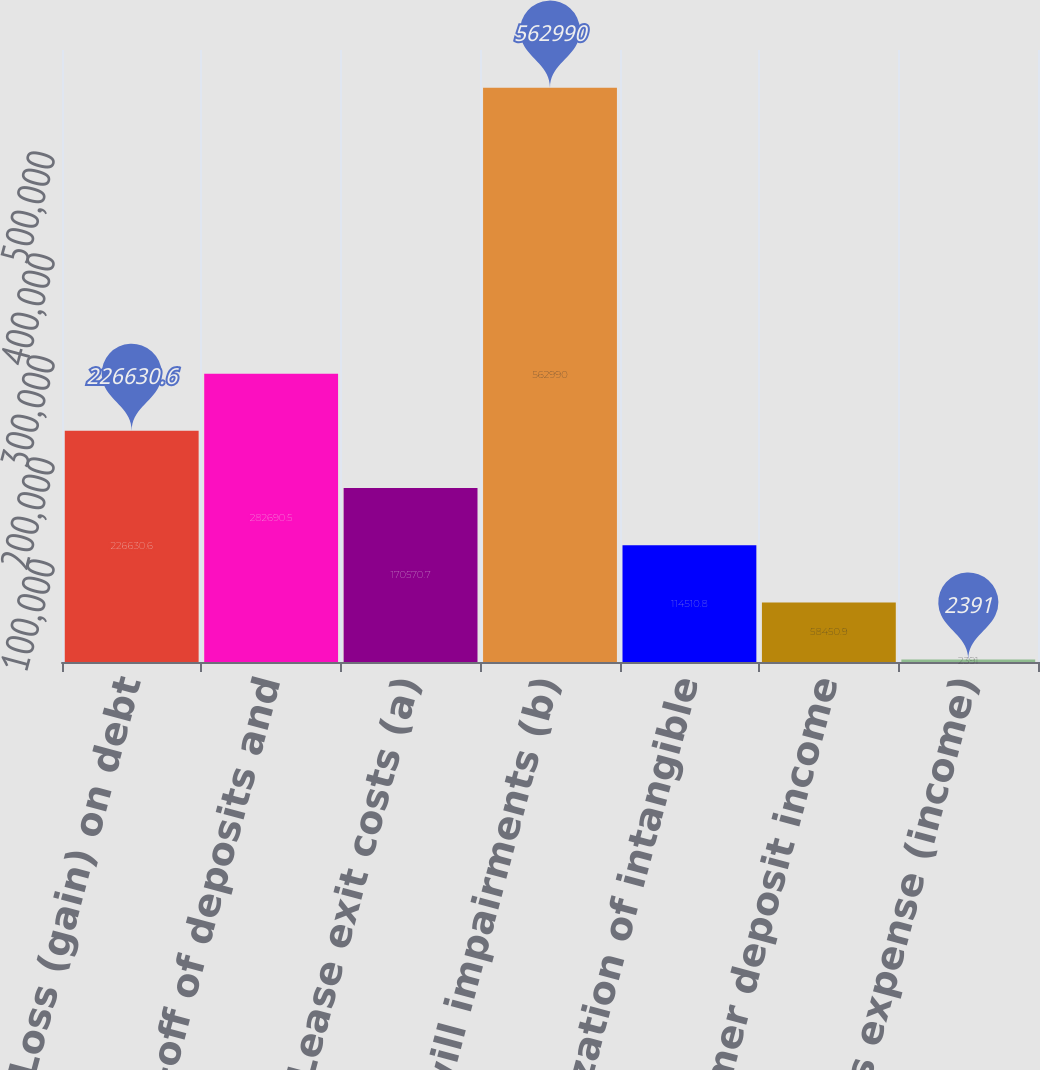<chart> <loc_0><loc_0><loc_500><loc_500><bar_chart><fcel>Loss (gain) on debt<fcel>Write-off of deposits and<fcel>Lease exit costs (a)<fcel>Goodwill impairments (b)<fcel>Amortization of intangible<fcel>Customer deposit income<fcel>Miscellaneous expense (income)<nl><fcel>226631<fcel>282690<fcel>170571<fcel>562990<fcel>114511<fcel>58450.9<fcel>2391<nl></chart> 